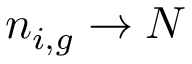Convert formula to latex. <formula><loc_0><loc_0><loc_500><loc_500>n _ { i , g } \to N</formula> 